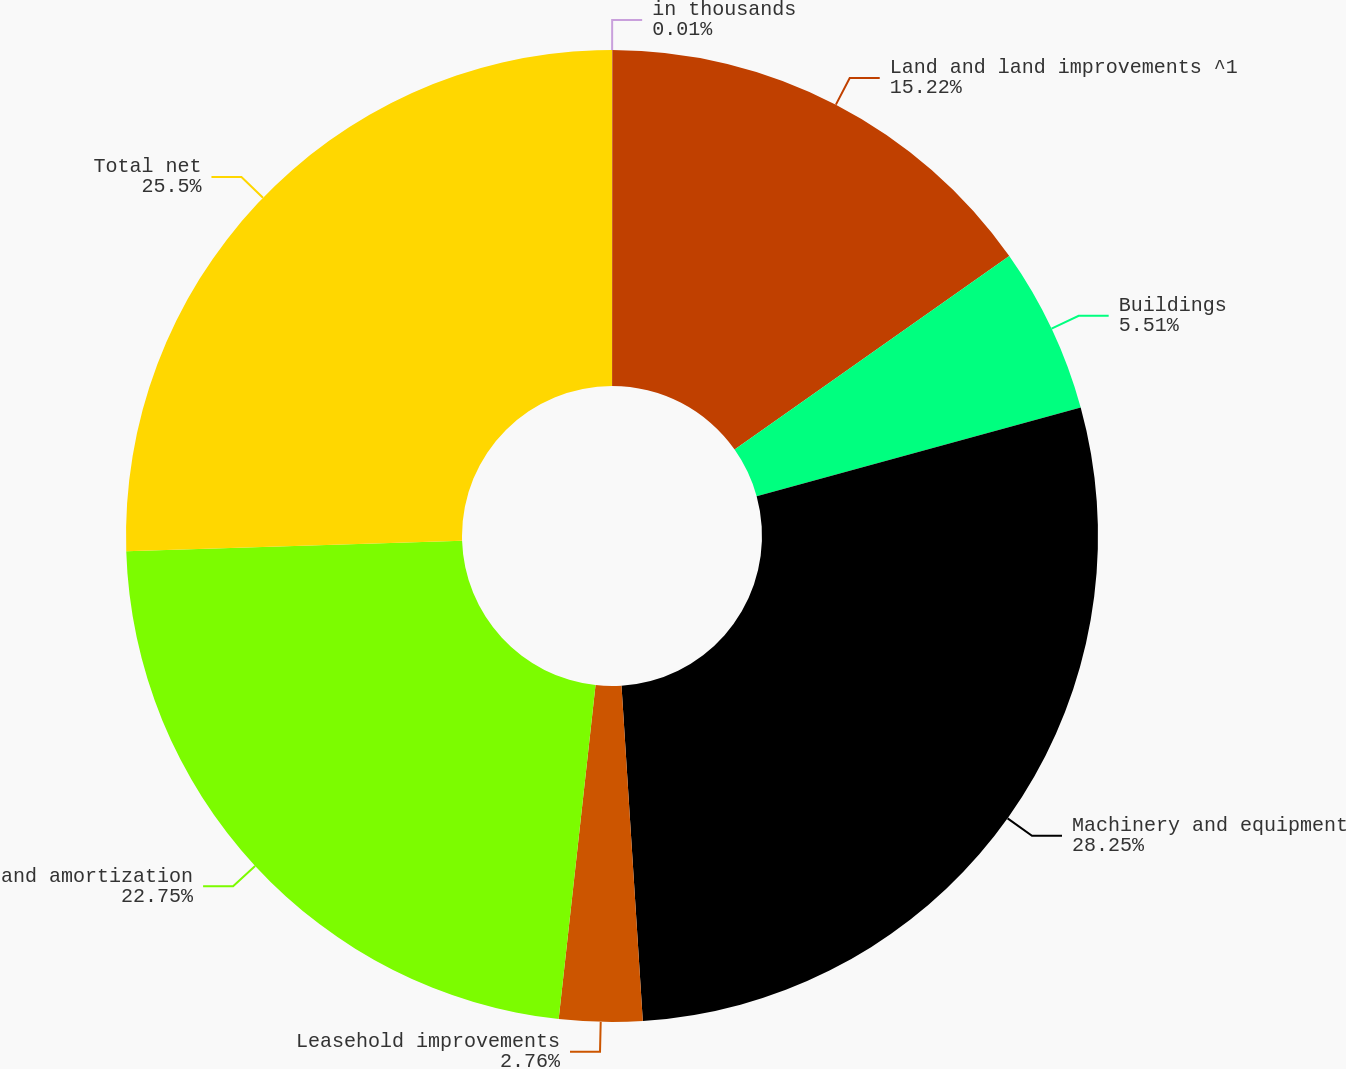<chart> <loc_0><loc_0><loc_500><loc_500><pie_chart><fcel>in thousands<fcel>Land and land improvements ^1<fcel>Buildings<fcel>Machinery and equipment<fcel>Leasehold improvements<fcel>and amortization<fcel>Total net<nl><fcel>0.01%<fcel>15.22%<fcel>5.51%<fcel>28.25%<fcel>2.76%<fcel>22.75%<fcel>25.5%<nl></chart> 